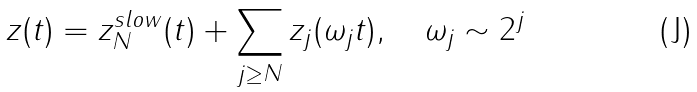Convert formula to latex. <formula><loc_0><loc_0><loc_500><loc_500>z ( t ) = z _ { N } ^ { s l o w } ( t ) + \sum _ { j \geq N } z _ { j } ( \omega _ { j } t ) , \quad \omega _ { j } \sim 2 ^ { j }</formula> 